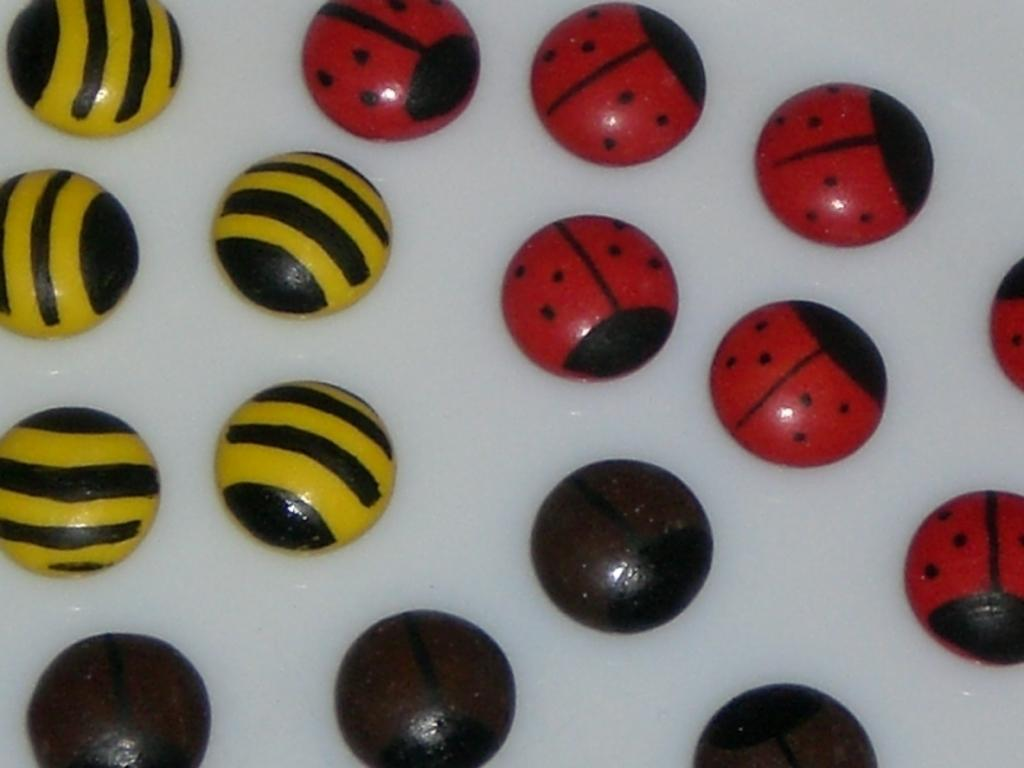What type of candy is present in the image? There are toffees in the image. Can you describe the appearance of the toffees? The toffees are in different colors. How are the toffees arranged in the image? The toffees are arranged on a surface. What color is the background of the image? The background of the image is white. How many chickens can be seen in the image? There are no chickens present in the image; it features toffees arranged on a surface with a white background. What type of wave is depicted in the image? There is no wave present in the image; it features toffees arranged on a surface with a white background. 